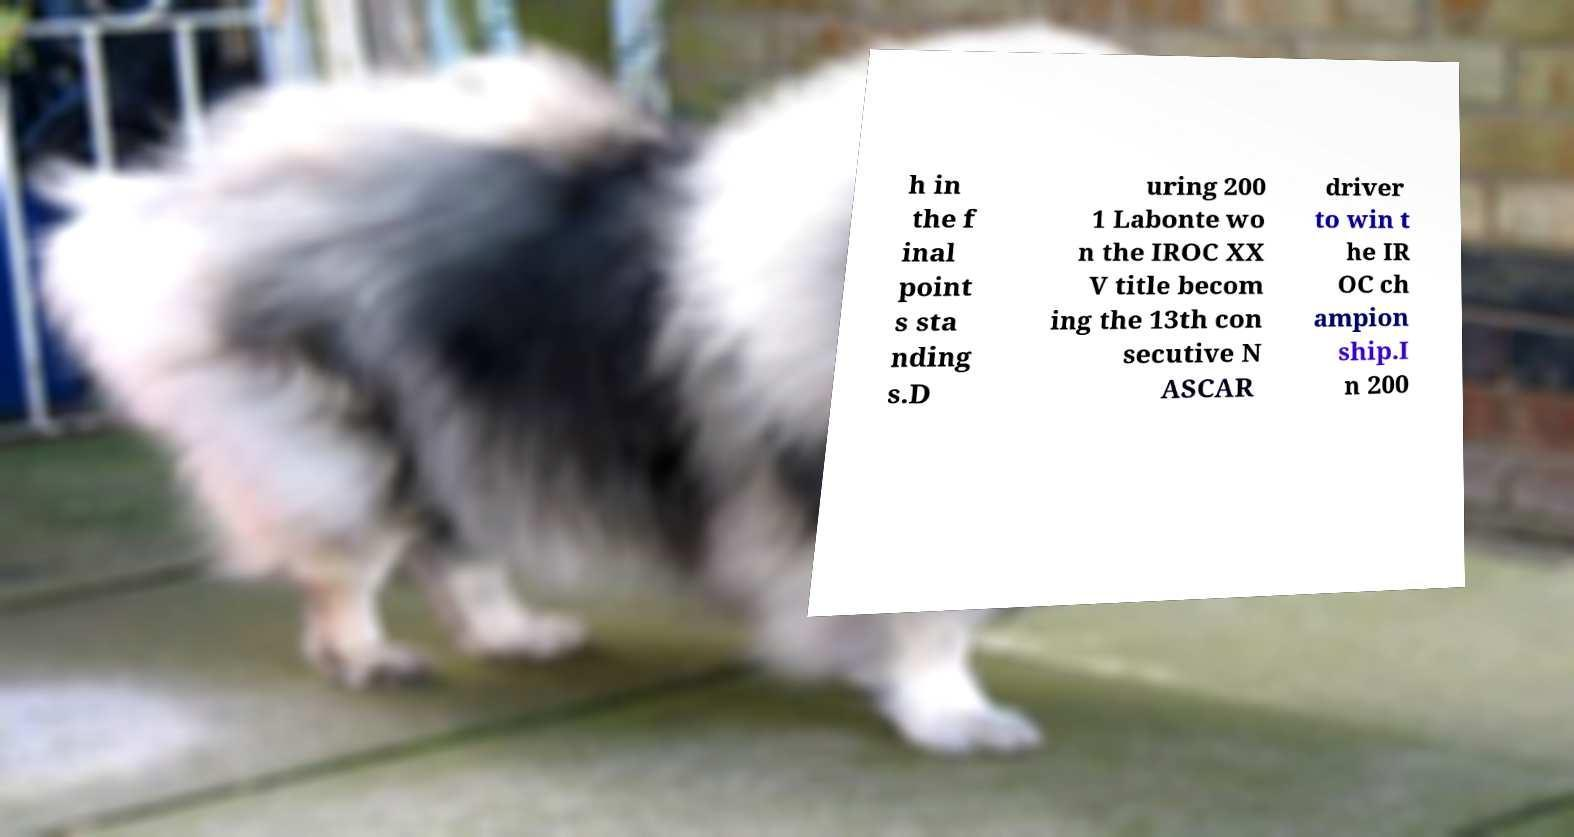Could you assist in decoding the text presented in this image and type it out clearly? h in the f inal point s sta nding s.D uring 200 1 Labonte wo n the IROC XX V title becom ing the 13th con secutive N ASCAR driver to win t he IR OC ch ampion ship.I n 200 